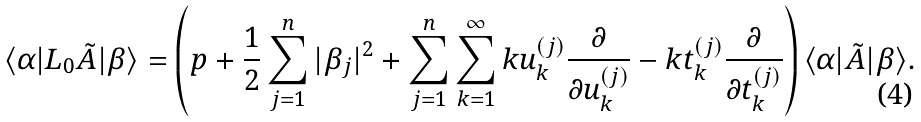Convert formula to latex. <formula><loc_0><loc_0><loc_500><loc_500>\langle \alpha | L _ { 0 } \tilde { A } | \beta \rangle = \left ( p + \frac { 1 } { 2 } \sum _ { j = 1 } ^ { n } | \beta _ { j } | ^ { 2 } + \sum _ { j = 1 } ^ { n } \sum _ { k = 1 } ^ { \infty } k u _ { k } ^ { ( j ) } \frac { \partial } { \partial u _ { k } ^ { ( j ) } } - k t _ { k } ^ { ( j ) } \frac { \partial } { \partial t _ { k } ^ { ( j ) } } \right ) \langle \alpha | \tilde { A } | \beta \rangle .</formula> 